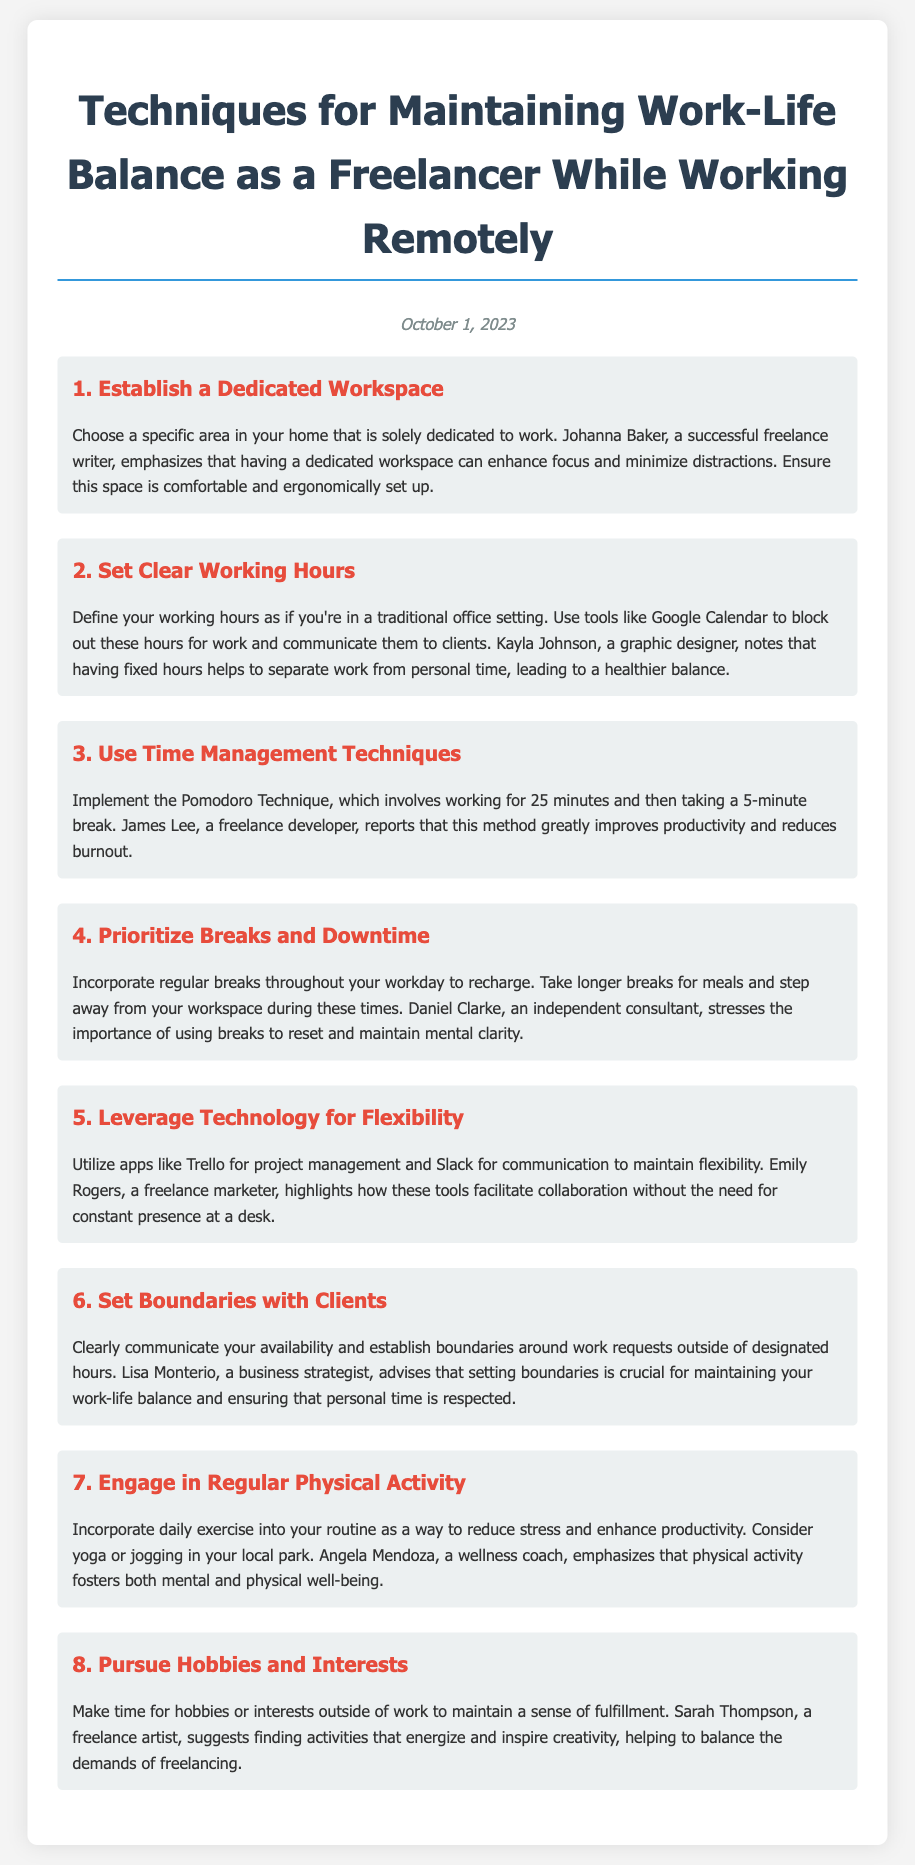What is the date of the document? The date mentioned at the top of the document is when it was published or created.
Answer: October 1, 2023 Who emphasizes the importance of a dedicated workspace? This information refers to a specific individual noted for their perspective on dedicating a workspace.
Answer: Johanna Baker What technique involves working for 25 minutes and taking a 5-minute break? This question pertains to a specific time management technique mentioned in the document.
Answer: Pomodoro Technique Which tool is recommended for project management? This question pertains to a specific app suggested for organizational purposes within freelance work.
Answer: Trello What is the importance of setting boundaries with clients? This question addresses a specific benefit of managing client expectations and communication.
Answer: Maintaining work-life balance What physical activity is suggested to reduce stress? This question looks for a specific type of exercise recommended for freelancers to improve their well-being.
Answer: Yoga What should freelancers prioritize to recharge? This question asks what freelancers should focus on during their workday to maintain their productivity and mental clarity.
Answer: Breaks Who suggests finding activities that energize and inspire creativity? This question seeks the name of the individual who advocates for engaging in hobbies or interests outside of work.
Answer: Sarah Thompson 